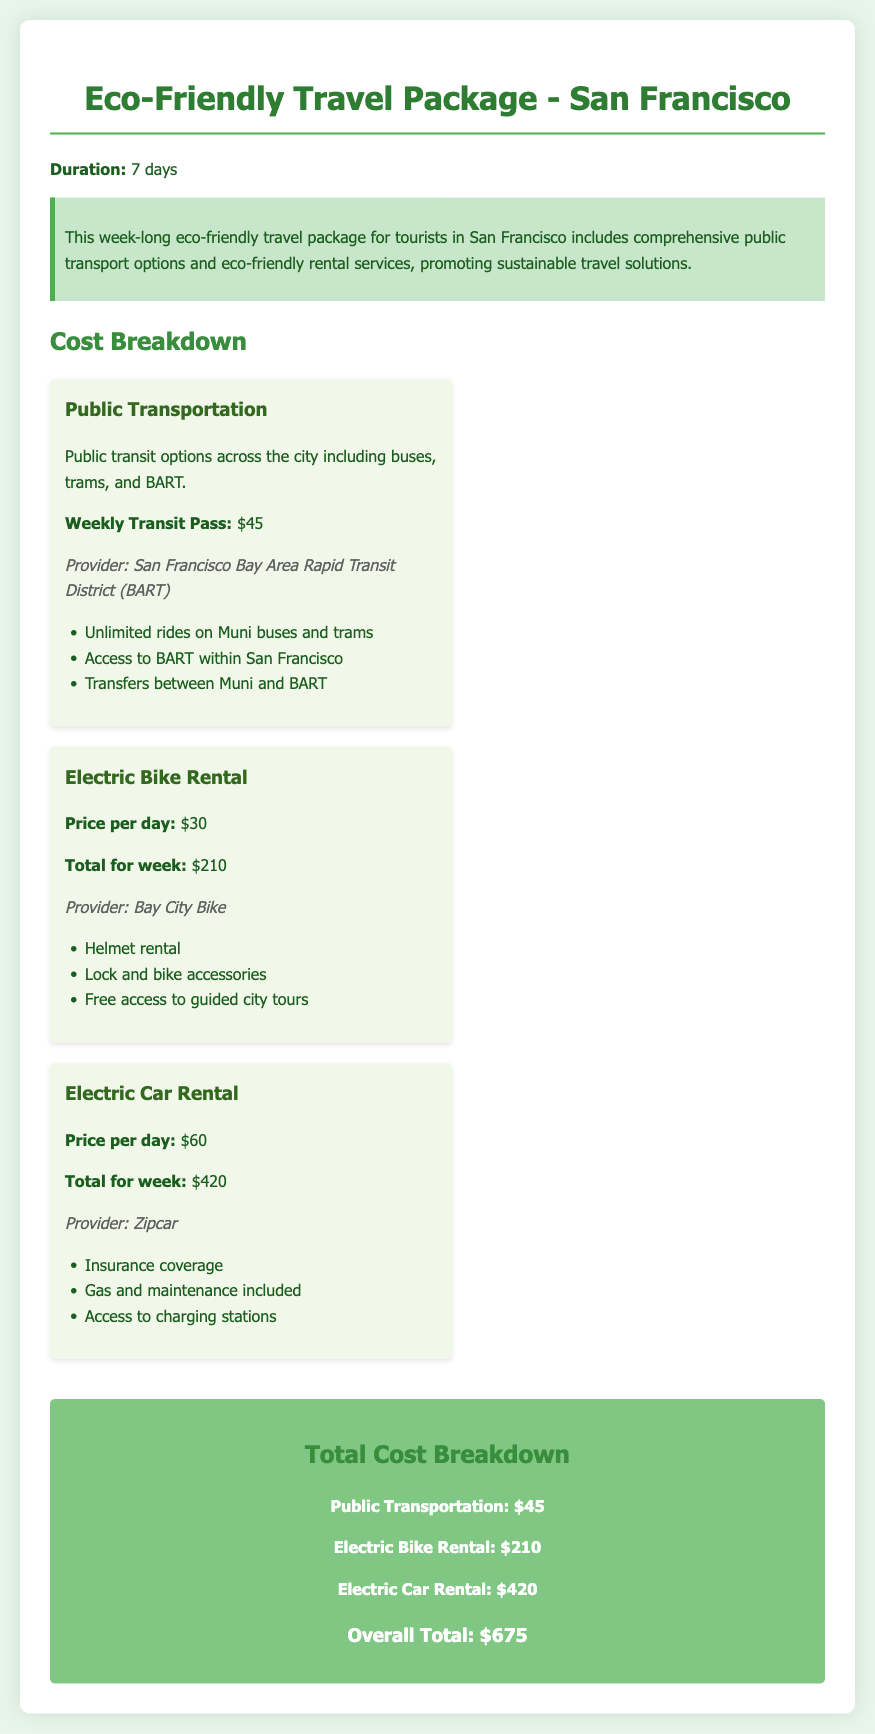what is the total cost of the travel package? The total cost of the travel package is calculated by adding the costs of public transportation, electric bike rental, and electric car rental, which totals $675.
Answer: $675 what is the price of the weekly transit pass? The price listed for the weekly transit pass provided by BART is mentioned in the document.
Answer: $45 how much does the electric bike rental cost per day? The document specifies the daily rental cost for an electric bike, which can be found in the electric bike rental section.
Answer: $30 what is included in the electric car rental? The electric car rental includes several services, as listed under the electric car rental cost item.
Answer: Insurance coverage, gas and maintenance included, access to charging stations what is the total cost of the electric car rental for the week? The total cost for the electric car rental across the week is outlined in the document, indicating the sum for seven days.
Answer: $420 who is the provider of the electric bike rental? The provider of the electric bike rental service is named in the rental section of the document.
Answer: Bay City Bike how many days is the travel package for? The duration of the eco-friendly travel package is explicitly stated at the beginning of the document.
Answer: 7 days what type of transport options are included in the public transportation section? A brief description lists the types of transport options available under the public transportation cost item.
Answer: Buses, trams, and BART what is the total cost of public transportation for a week? The document details the weekly cost of public transportation specifically in the cost breakdown section.
Answer: $45 